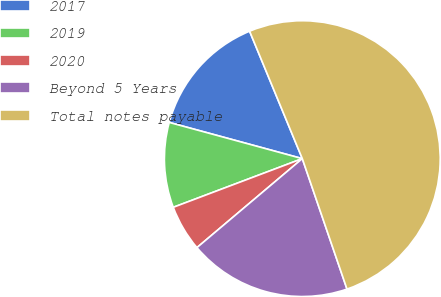Convert chart to OTSL. <chart><loc_0><loc_0><loc_500><loc_500><pie_chart><fcel>2017<fcel>2019<fcel>2020<fcel>Beyond 5 Years<fcel>Total notes payable<nl><fcel>14.53%<fcel>9.97%<fcel>5.42%<fcel>19.09%<fcel>50.99%<nl></chart> 